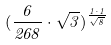<formula> <loc_0><loc_0><loc_500><loc_500>( \frac { 6 } { 2 6 8 } \cdot \sqrt { 3 } ) ^ { \frac { 1 \cdot 1 } { \sqrt { 8 } } }</formula> 